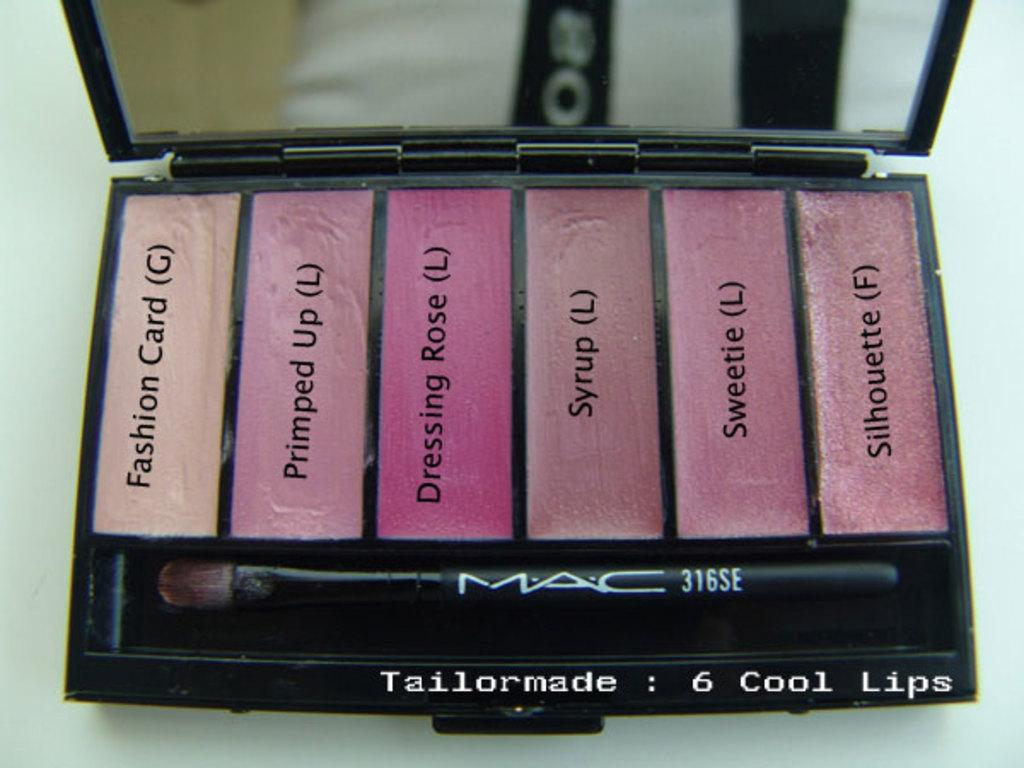<image>
Present a compact description of the photo's key features. A palette from Mac has 6 cool lip colors. 